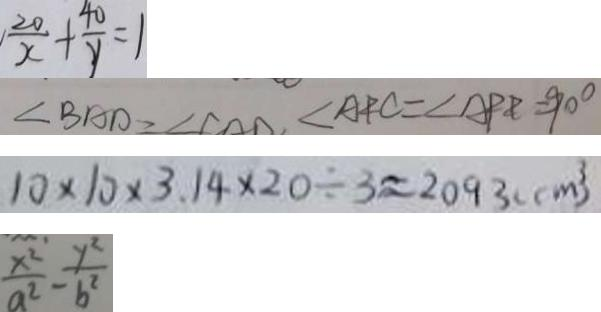Convert formula to latex. <formula><loc_0><loc_0><loc_500><loc_500>\frac { 2 0 } { x } + \frac { 4 0 } { y } = 1 
 \angle B A D = \angle C O D = \angle A F C = \angle A P E = 9 0 ^ { \circ } 
 1 0 \times 1 0 \times 3 . 1 4 \times 2 0 \div 3 \approx 2 0 9 3 ( c m ^ { 3 } ) 
 \frac { x ^ { 2 } } { a ^ { 2 } } - \frac { y ^ { 2 } } { b ^ { 2 } }</formula> 